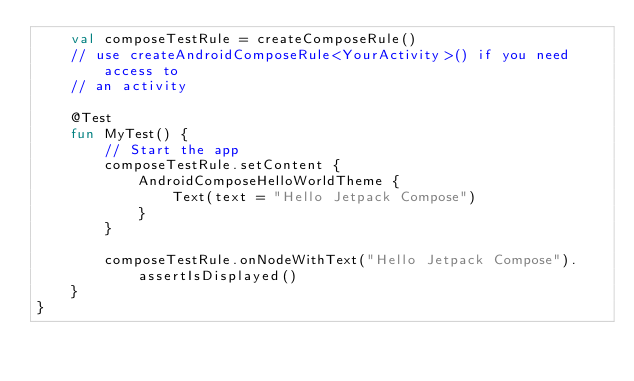<code> <loc_0><loc_0><loc_500><loc_500><_Kotlin_>    val composeTestRule = createComposeRule()
    // use createAndroidComposeRule<YourActivity>() if you need access to
    // an activity

    @Test
    fun MyTest() {
        // Start the app
        composeTestRule.setContent {
            AndroidComposeHelloWorldTheme {
                Text(text = "Hello Jetpack Compose")
            }
        }

        composeTestRule.onNodeWithText("Hello Jetpack Compose").assertIsDisplayed()
    }
}
</code> 